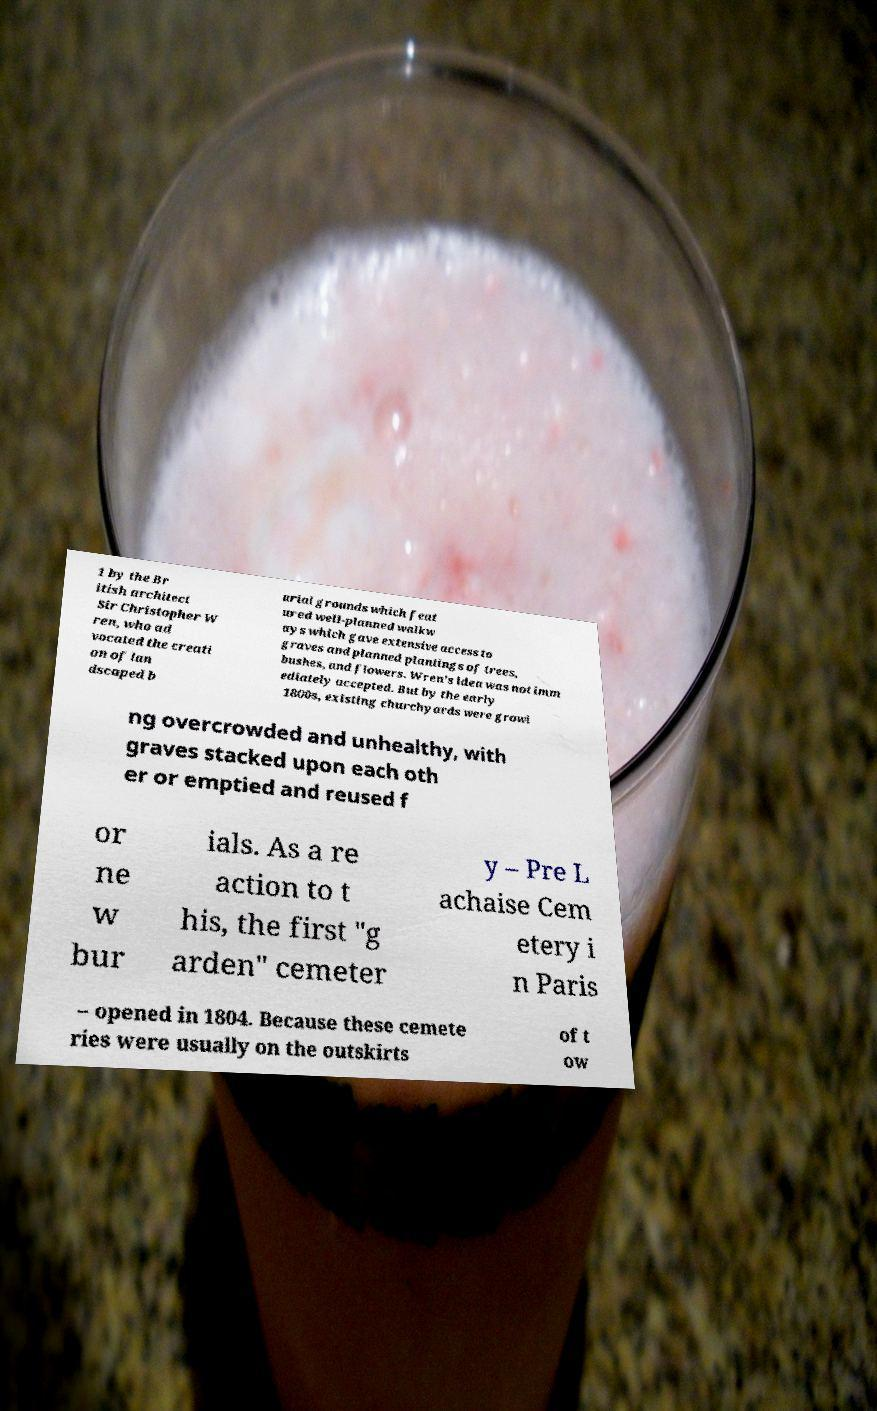What messages or text are displayed in this image? I need them in a readable, typed format. 1 by the Br itish architect Sir Christopher W ren, who ad vocated the creati on of lan dscaped b urial grounds which feat ured well-planned walkw ays which gave extensive access to graves and planned plantings of trees, bushes, and flowers. Wren's idea was not imm ediately accepted. But by the early 1800s, existing churchyards were growi ng overcrowded and unhealthy, with graves stacked upon each oth er or emptied and reused f or ne w bur ials. As a re action to t his, the first "g arden" cemeter y – Pre L achaise Cem etery i n Paris – opened in 1804. Because these cemete ries were usually on the outskirts of t ow 